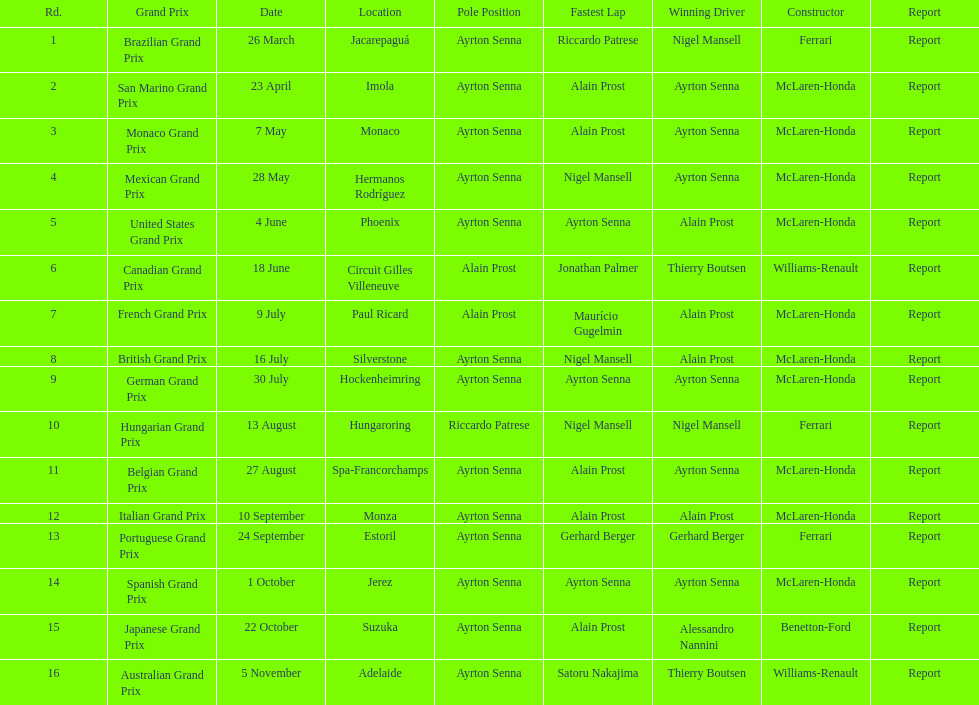Who achieved the fastest lap time at the german grand prix? Ayrton Senna. 